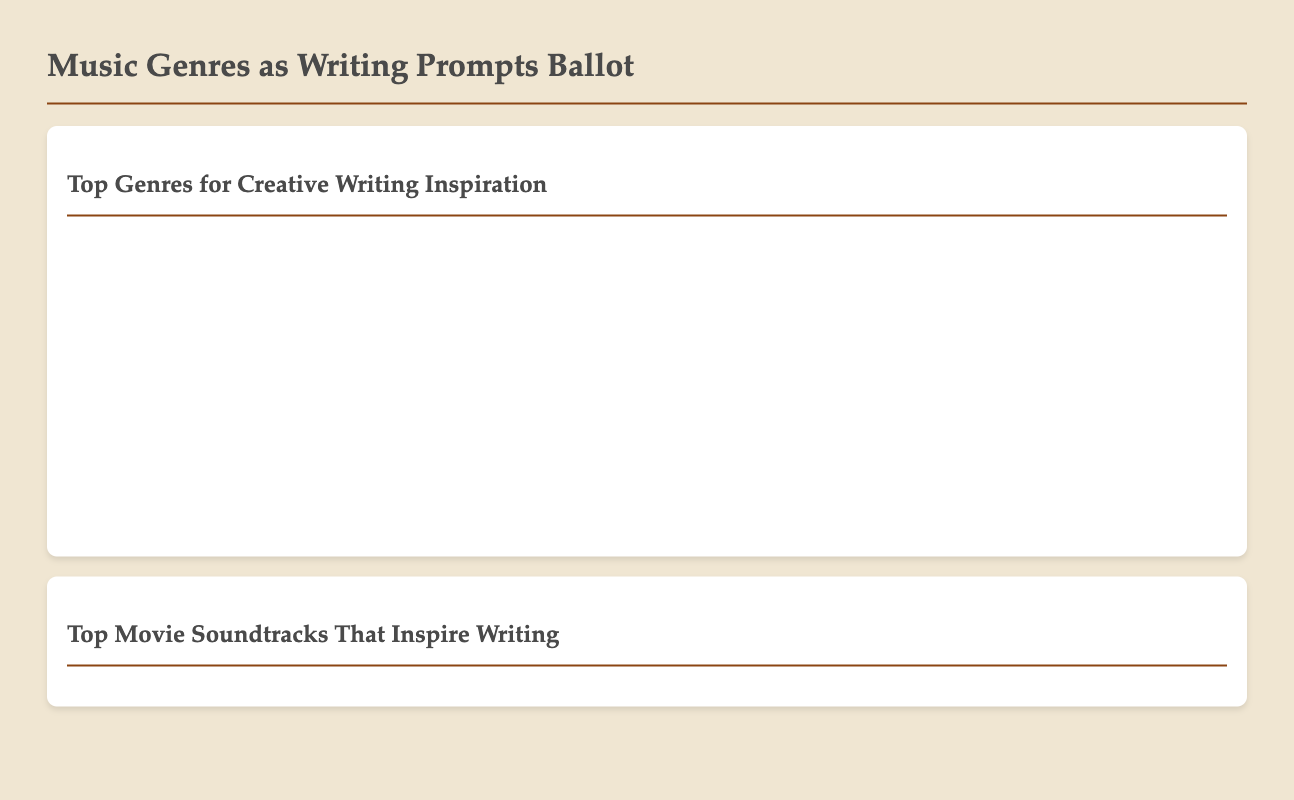What genre received the highest number of votes? The highest number of votes is for Classical with 18,000 votes.
Answer: Classical How many votes did Indie Rock receive? Indie Rock received 10,000 votes as indicated in the document.
Answer: 10,000 Which composer is mentioned as inspiring profound storytelling? The document attributes this influence to the soundtrack of Interstellar.
Answer: Interstellar What is the total number of votes for Jazz? Jazz received a total of 15,000 votes according to the ballot results.
Answer: 15,000 Which soundtrack received the least number of votes? Amélie received the least votes, totaling 8,000.
Answer: Amélie What reason is given for the popularity of Ambient music among writers? The reason given is that Ambient music offers an unobtrusive background to help writers maintain focus.
Answer: Unobtrusive background How many voters found the score of Inception moving and thought-provoking? The document features multiple testimonials, indicating it was a common sentiment among at least two authors.
Answer: Two authors What is the primary function of movie soundtracks as per the document? The primary function is to enhance the writer's imaginative process.
Answer: Enhance imagination Which genre had the second-highest vote count? Jazz had the second-highest vote count with 15,000 votes.
Answer: Jazz 